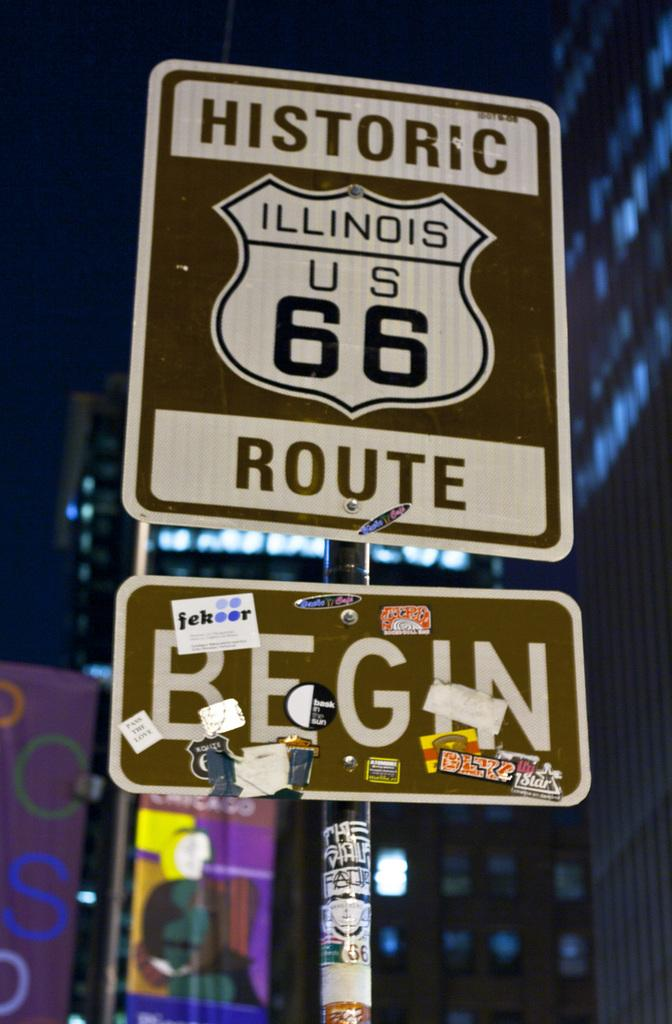<image>
Describe the image concisely. Sign on the road that says Historic route Begin 